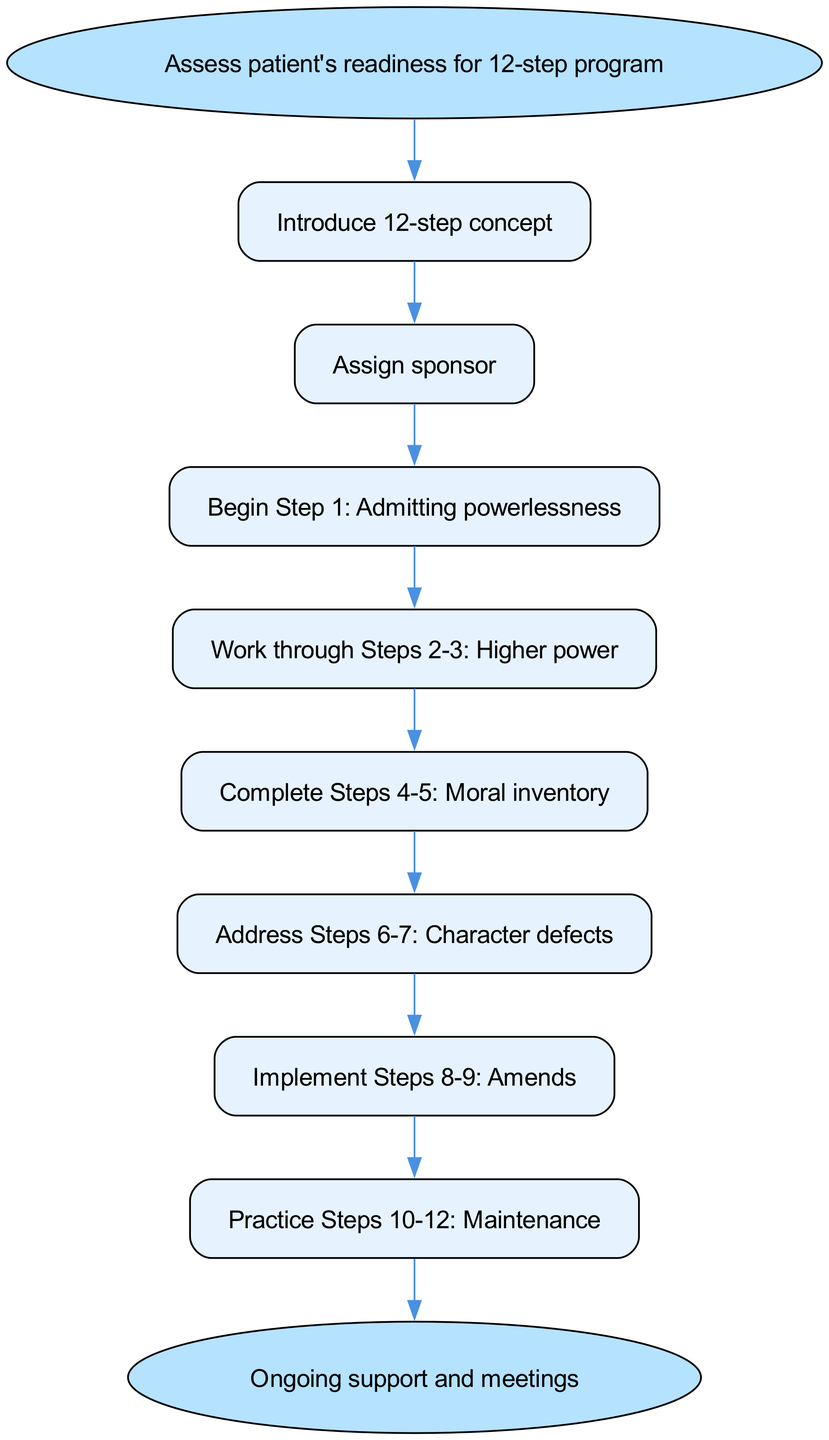What is the first step in the recovery program? The diagram indicates the first step is to "Introduce 12-step concept," directly connected from the start node.
Answer: Introduce 12-step concept How many steps are there in total? Counting the steps listed in the diagram, there are 8 steps, leading from the start node to the end node.
Answer: 8 What step follows "Address Steps 6-7: Character defects"? The diagram shows that the next step after "Address Steps 6-7: Character defects" is "Implement Steps 8-9: Amends," indicating a direct flow to this step.
Answer: Implement Steps 8-9: Amends What is the last action taken in the recovery program? The end node reveals that the last action in the program is "Ongoing support and meetings," which signifies the conclusion of the steps outlined.
Answer: Ongoing support and meetings Which step is immediately before "Practice Steps 10-12: Maintenance"? The diagram directly indicates that "Implement Steps 8-9: Amends" precedes "Practice Steps 10-12: Maintenance," showcasing the sequential relationship between these two steps.
Answer: Implement Steps 8-9: Amends What is the relationship between "Begin Step 1: Admitting powerlessness" and "Assign sponsor"? "Begin Step 1: Admitting powerlessness" follows "Assign sponsor," indicating a directional flow from the latter to the former as part of the process.
Answer: Assign sponsor → Begin Step 1: Admitting powerlessness How does the process conclude based on the diagram? The diagram concludes with "Ongoing support and meetings," flowing from "Practice Steps 10-12: Maintenance," wrapping up the recovery program in a continuous loop of support.
Answer: Ongoing support and meetings Which step introduces the concept of the 12-step recovery program? The first step, indicated in the diagram, is "Introduce 12-step concept," signaling the initiation of the program's framework.
Answer: Introduce 12-step concept 